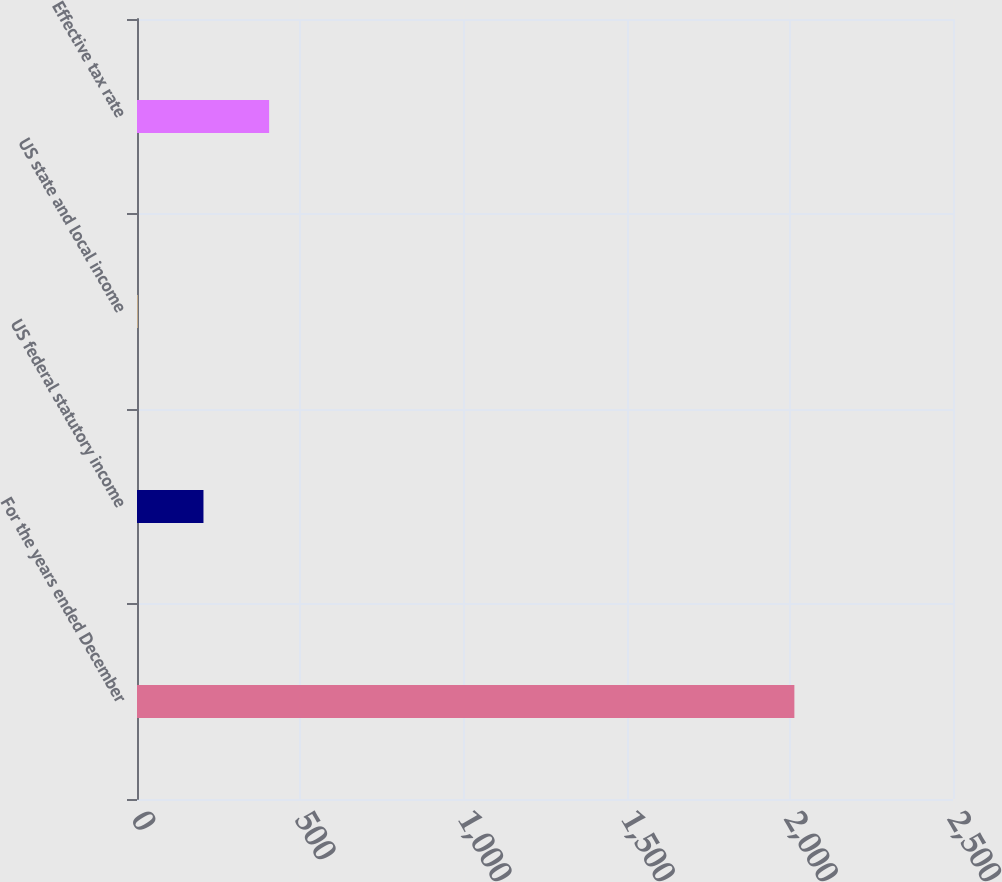Convert chart. <chart><loc_0><loc_0><loc_500><loc_500><bar_chart><fcel>For the years ended December<fcel>US federal statutory income<fcel>US state and local income<fcel>Effective tax rate<nl><fcel>2014<fcel>203.65<fcel>2.5<fcel>404.8<nl></chart> 